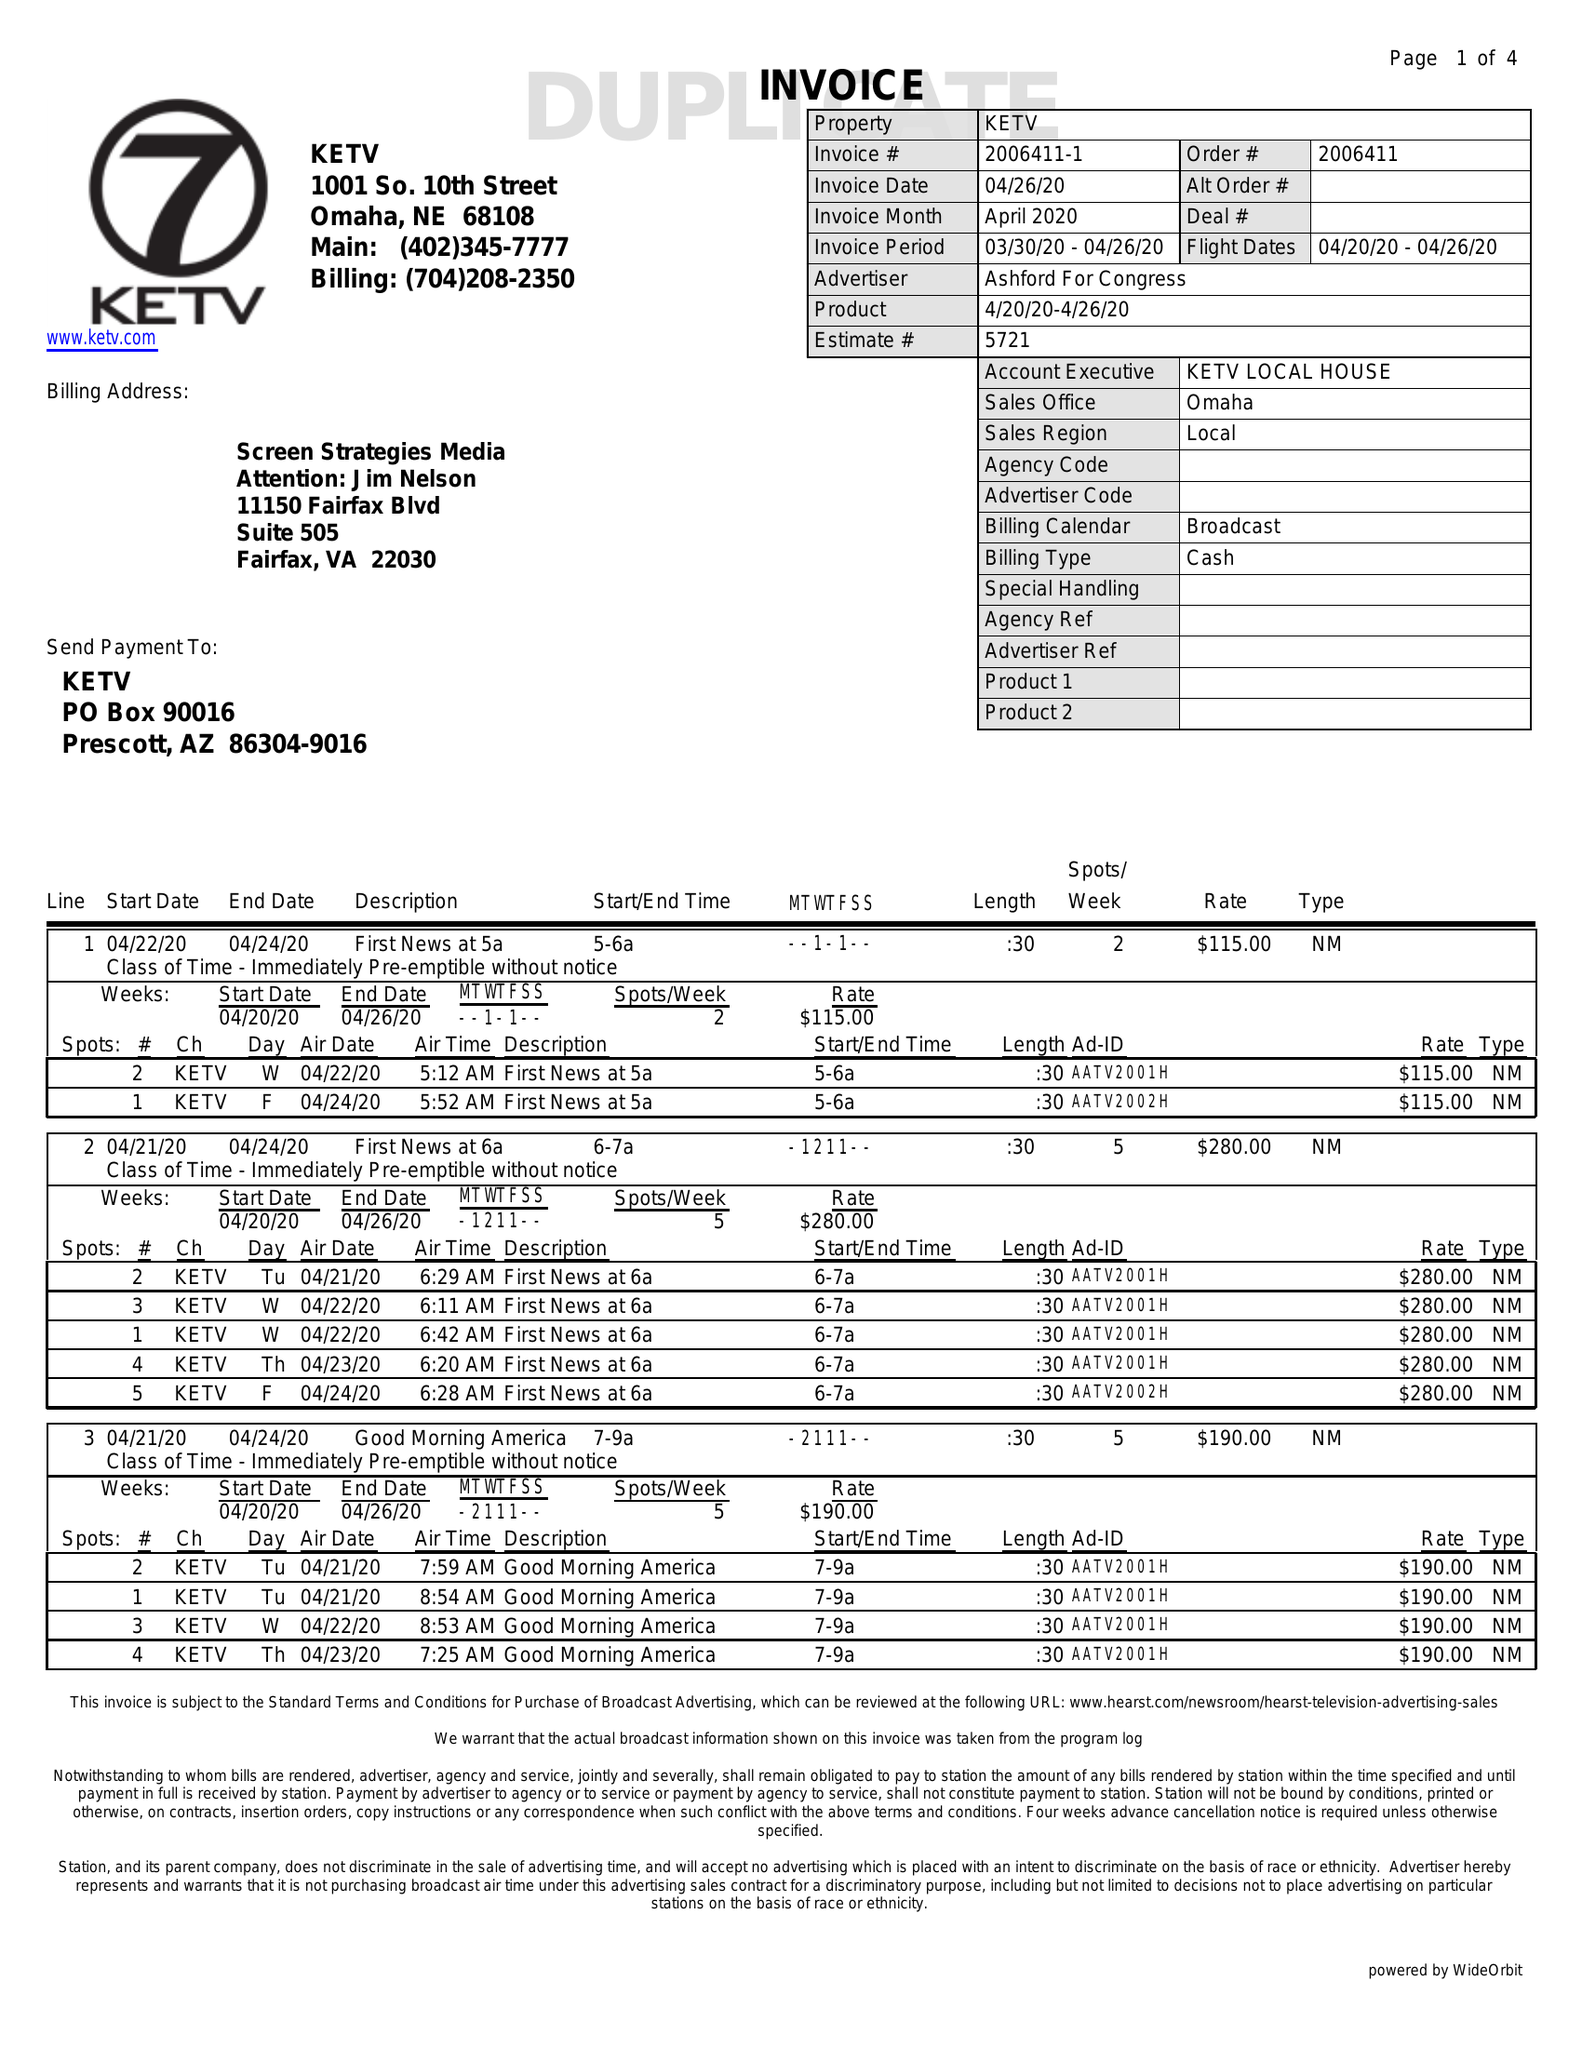What is the value for the flight_from?
Answer the question using a single word or phrase. 04/20/20 